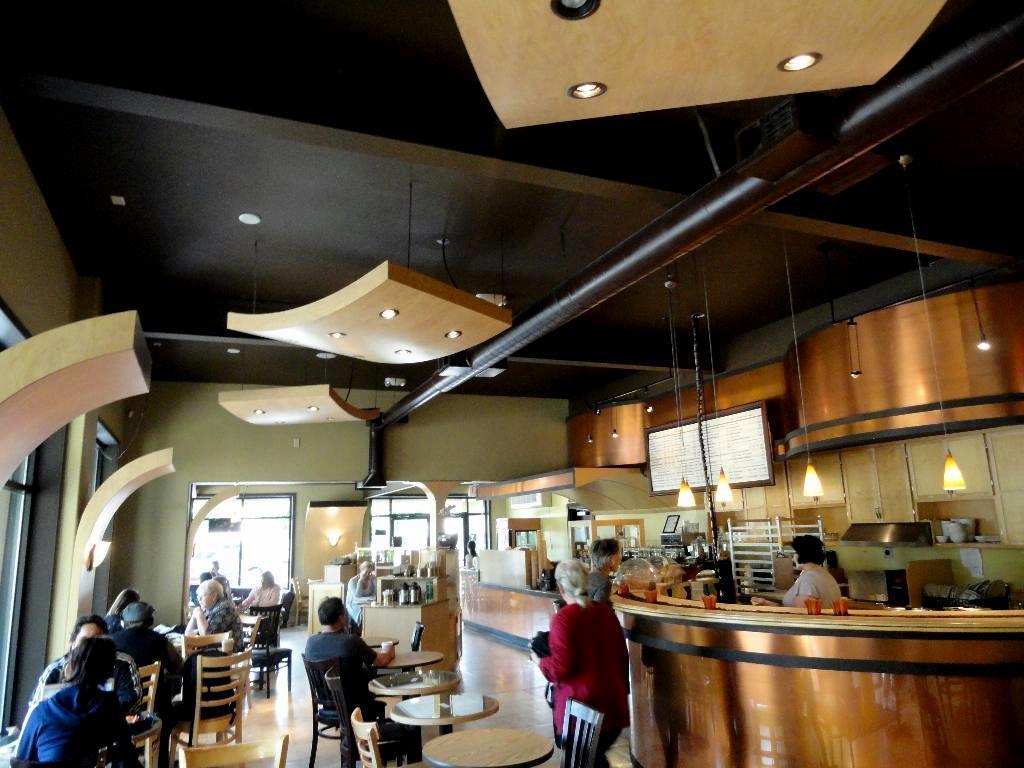Could you give a brief overview of what you see in this image? In this image, there are some persons sitting on the chair in front of the table. There are some lights at the top. This person is standing behind this table. There is window attached to the wall. There are some flasks on the table. 